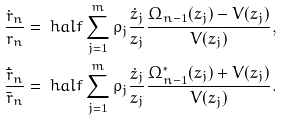<formula> <loc_0><loc_0><loc_500><loc_500>\frac { \dot { r } _ { n } } { r _ { n } } & = \ h a l f \sum ^ { m } _ { j = 1 } \rho _ { j } \frac { \dot { z } _ { j } } { z _ { j } } \frac { \Omega _ { n - 1 } ( z _ { j } ) - V ( z _ { j } ) } { V ( z _ { j } ) } , \\ \frac { \dot { \bar { r } } _ { n } } { \bar { r } _ { n } } & = \ h a l f \sum ^ { m } _ { j = 1 } \rho _ { j } \frac { \dot { z } _ { j } } { z _ { j } } \frac { \Omega ^ { * } _ { n - 1 } ( z _ { j } ) + V ( z _ { j } ) } { V ( z _ { j } ) } .</formula> 